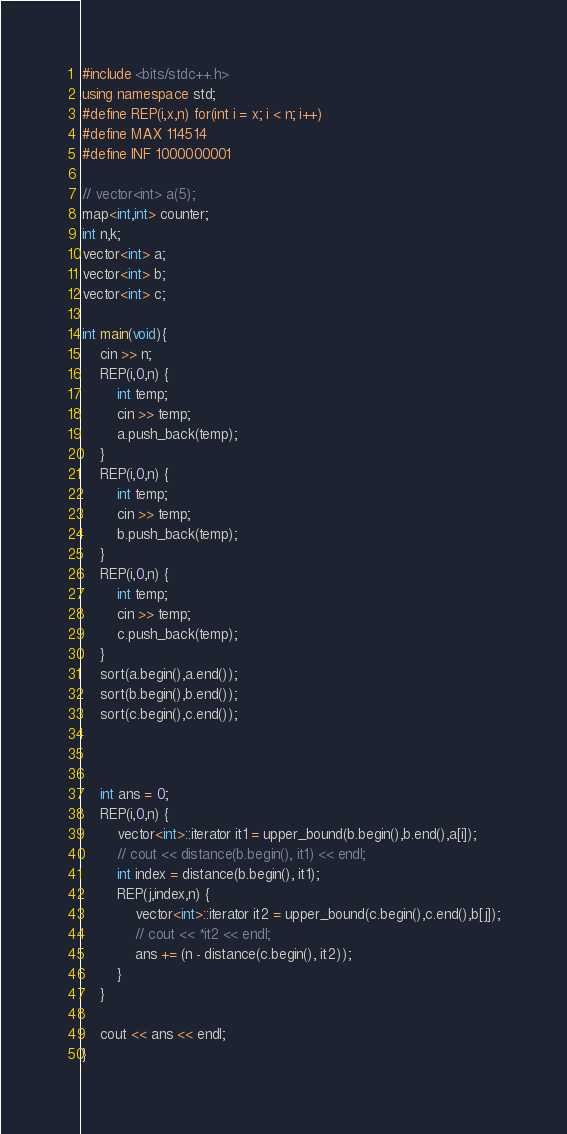Convert code to text. <code><loc_0><loc_0><loc_500><loc_500><_C++_>#include <bits/stdc++.h>
using namespace std;
#define REP(i,x,n) for(int i = x; i < n; i++)
#define MAX 114514
#define INF 1000000001

// vector<int> a(5);
map<int,int> counter;
int n,k;
vector<int> a;
vector<int> b;
vector<int> c;

int main(void){
    cin >> n;
    REP(i,0,n) {
        int temp;
        cin >> temp;
        a.push_back(temp);
    }
    REP(i,0,n) {
        int temp;
        cin >> temp;
        b.push_back(temp);
    }
    REP(i,0,n) {
        int temp;
        cin >> temp;
        c.push_back(temp);
    }
    sort(a.begin(),a.end());
    sort(b.begin(),b.end());
    sort(c.begin(),c.end());
    
    
    
    int ans = 0;
    REP(i,0,n) {
        vector<int>::iterator it1 = upper_bound(b.begin(),b.end(),a[i]);
        // cout << distance(b.begin(), it1) << endl;
        int index = distance(b.begin(), it1);
        REP(j,index,n) {
            vector<int>::iterator it2 = upper_bound(c.begin(),c.end(),b[j]);
            // cout << *it2 << endl;
            ans += (n - distance(c.begin(), it2));
        }
    }
    
    cout << ans << endl;
}</code> 